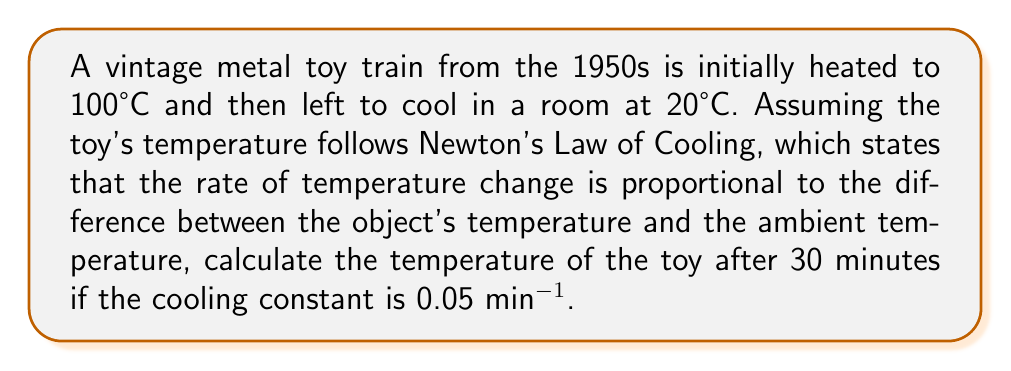Help me with this question. Let's approach this step-by-step using Newton's Law of Cooling:

1) The general form of Newton's Law of Cooling is:

   $$\frac{dT}{dt} = -k(T - T_a)$$

   where $T$ is the temperature of the object, $T_a$ is the ambient temperature, $t$ is time, and $k$ is the cooling constant.

2) The solution to this differential equation is:

   $$T(t) = T_a + (T_0 - T_a)e^{-kt}$$

   where $T_0$ is the initial temperature of the object.

3) We're given:
   - $T_0 = 100°C$ (initial temperature of the toy)
   - $T_a = 20°C$ (ambient room temperature)
   - $k = 0.05 \text{ min}^{-1}$ (cooling constant)
   - $t = 30 \text{ minutes}$ (time elapsed)

4) Let's substitute these values into our equation:

   $$T(30) = 20 + (100 - 20)e^{-0.05 \cdot 30}$$

5) Simplify:
   $$T(30) = 20 + 80e^{-1.5}$$

6) Calculate:
   $$T(30) = 20 + 80 \cdot 0.2231 \approx 37.85°C$$

Therefore, after 30 minutes, the temperature of the vintage metal toy train will be approximately 37.85°C.
Answer: 37.85°C 